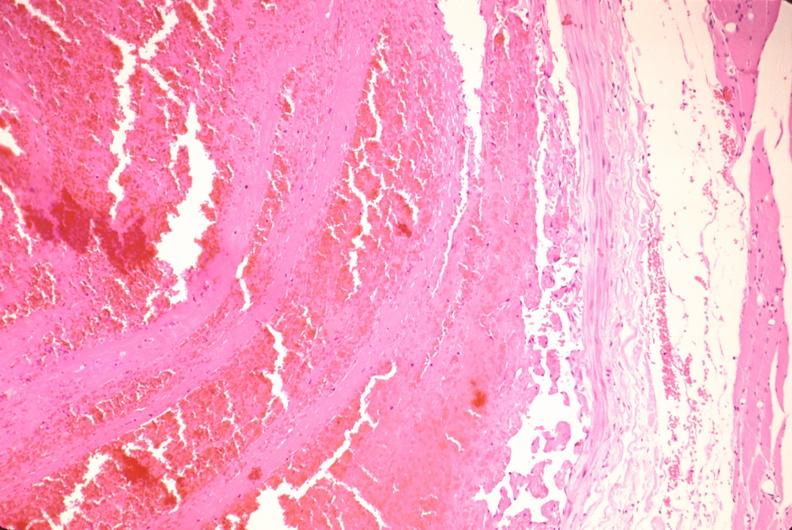how does this image show thrombus in leg vein?
Answer the question using a single word or phrase. With early organization 